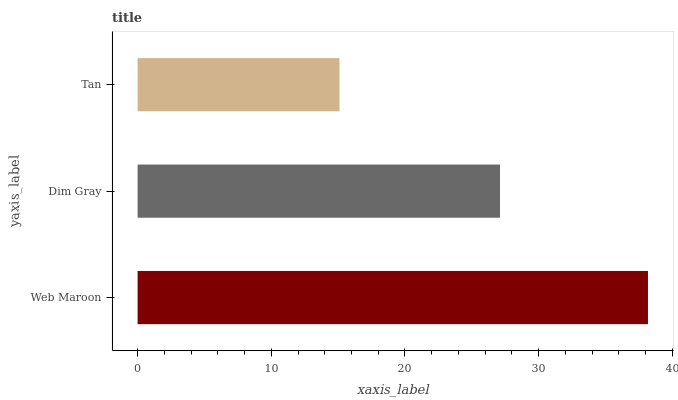Is Tan the minimum?
Answer yes or no. Yes. Is Web Maroon the maximum?
Answer yes or no. Yes. Is Dim Gray the minimum?
Answer yes or no. No. Is Dim Gray the maximum?
Answer yes or no. No. Is Web Maroon greater than Dim Gray?
Answer yes or no. Yes. Is Dim Gray less than Web Maroon?
Answer yes or no. Yes. Is Dim Gray greater than Web Maroon?
Answer yes or no. No. Is Web Maroon less than Dim Gray?
Answer yes or no. No. Is Dim Gray the high median?
Answer yes or no. Yes. Is Dim Gray the low median?
Answer yes or no. Yes. Is Web Maroon the high median?
Answer yes or no. No. Is Web Maroon the low median?
Answer yes or no. No. 